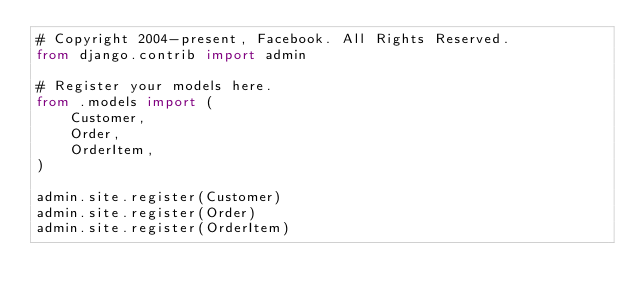<code> <loc_0><loc_0><loc_500><loc_500><_Python_># Copyright 2004-present, Facebook. All Rights Reserved.
from django.contrib import admin

# Register your models here.
from .models import (
    Customer,
    Order,
    OrderItem,
)

admin.site.register(Customer)
admin.site.register(Order)
admin.site.register(OrderItem)
</code> 